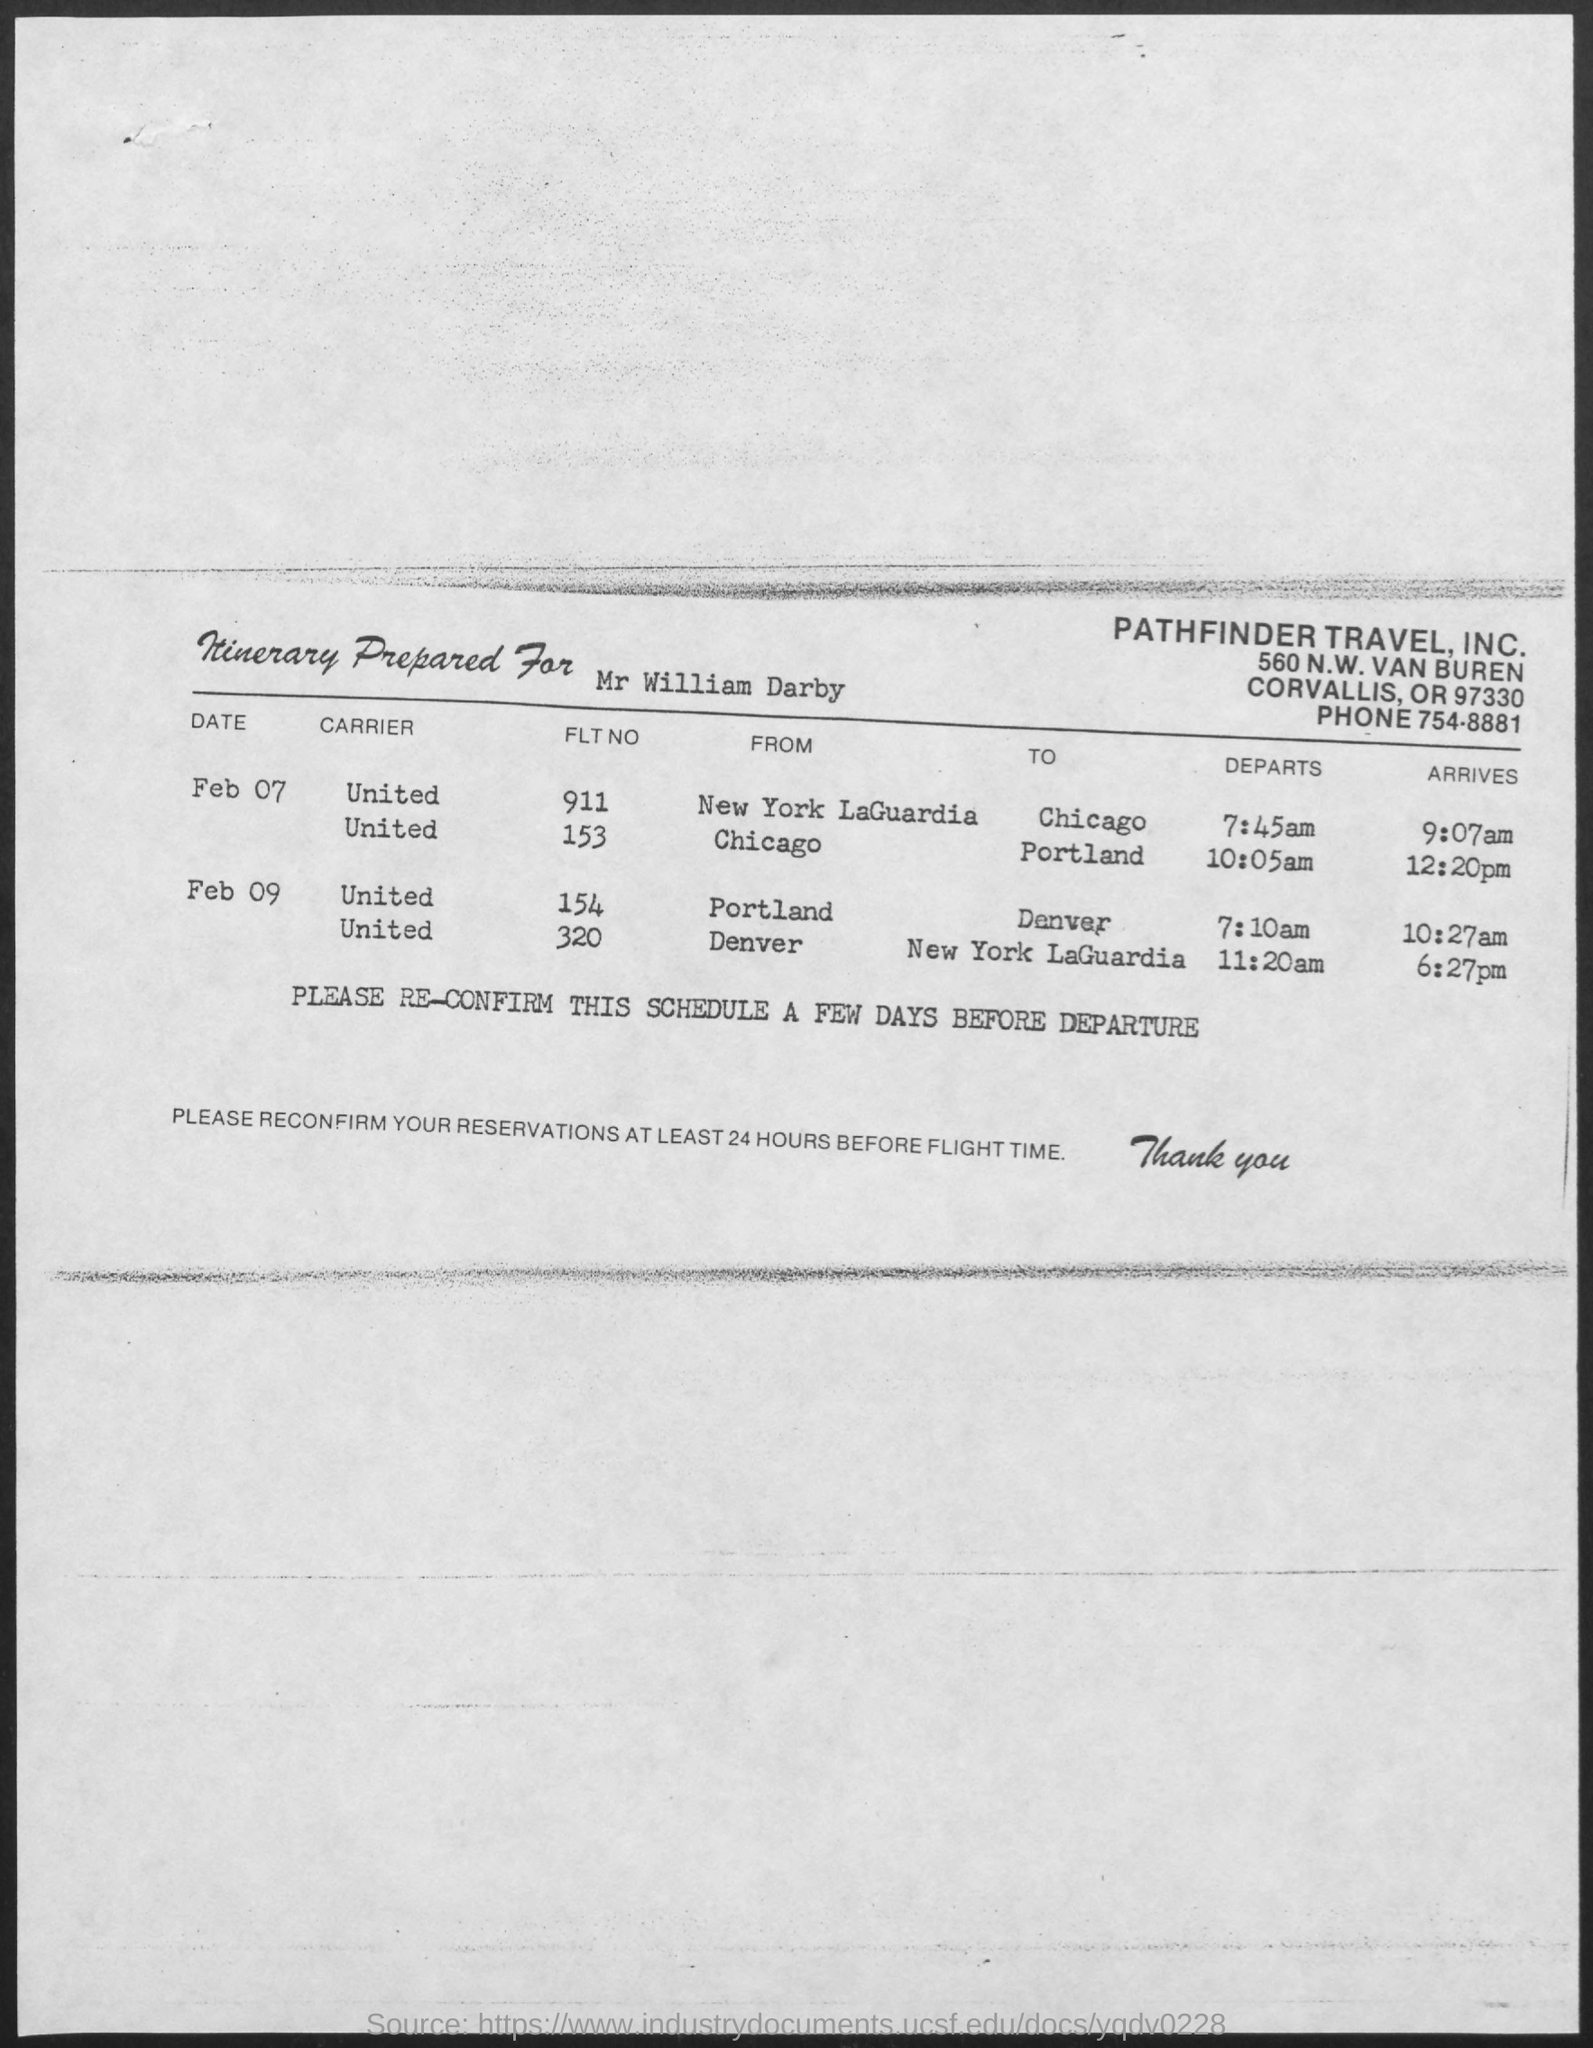Point out several critical features in this image. On February 9th at 7:10 am, the flight number from Portland to Denver is 154. The phone number mentioned in the document is 754-8881. 